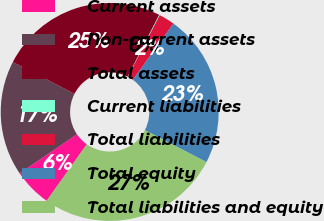<chart> <loc_0><loc_0><loc_500><loc_500><pie_chart><fcel>Current assets<fcel>Non-current assets<fcel>Total assets<fcel>Current liabilities<fcel>Total liabilities<fcel>Total equity<fcel>Total liabilities and equity<nl><fcel>5.66%<fcel>17.1%<fcel>24.93%<fcel>0.09%<fcel>2.36%<fcel>22.66%<fcel>27.2%<nl></chart> 